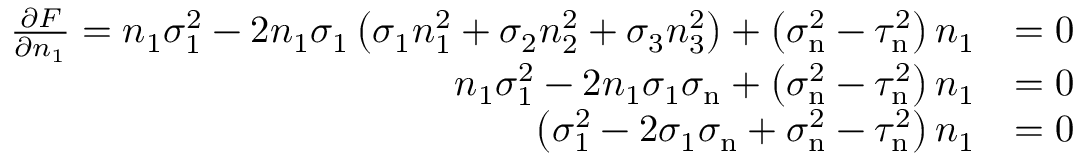Convert formula to latex. <formula><loc_0><loc_0><loc_500><loc_500>{ \begin{array} { r l } { { \frac { \partial F } { \partial n _ { 1 } } } = n _ { 1 } \sigma _ { 1 } ^ { 2 } - 2 n _ { 1 } \sigma _ { 1 } \left ( \sigma _ { 1 } n _ { 1 } ^ { 2 } + \sigma _ { 2 } n _ { 2 } ^ { 2 } + \sigma _ { 3 } n _ { 3 } ^ { 2 } \right ) + \left ( \sigma _ { n } ^ { 2 } - \tau _ { n } ^ { 2 } \right ) n _ { 1 } } & { = 0 } \\ { n _ { 1 } \sigma _ { 1 } ^ { 2 } - 2 n _ { 1 } \sigma _ { 1 } \sigma _ { n } + \left ( \sigma _ { n } ^ { 2 } - \tau _ { n } ^ { 2 } \right ) n _ { 1 } } & { = 0 } \\ { \left ( \sigma _ { 1 } ^ { 2 } - 2 \sigma _ { 1 } \sigma _ { n } + \sigma _ { n } ^ { 2 } - \tau _ { n } ^ { 2 } \right ) n _ { 1 } } & { = 0 } \end{array} }</formula> 